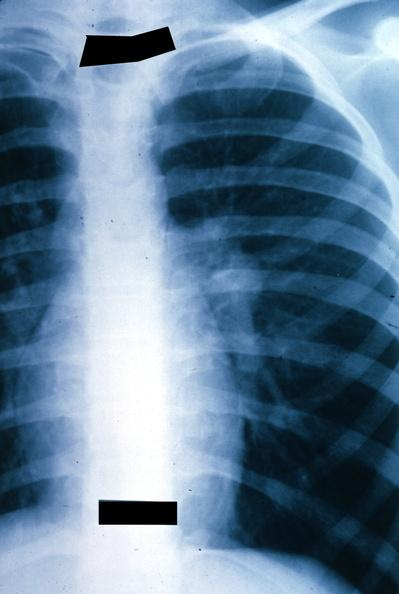does this image show x-ray chest left hilar mass tumor in hilar node?
Answer the question using a single word or phrase. Yes 